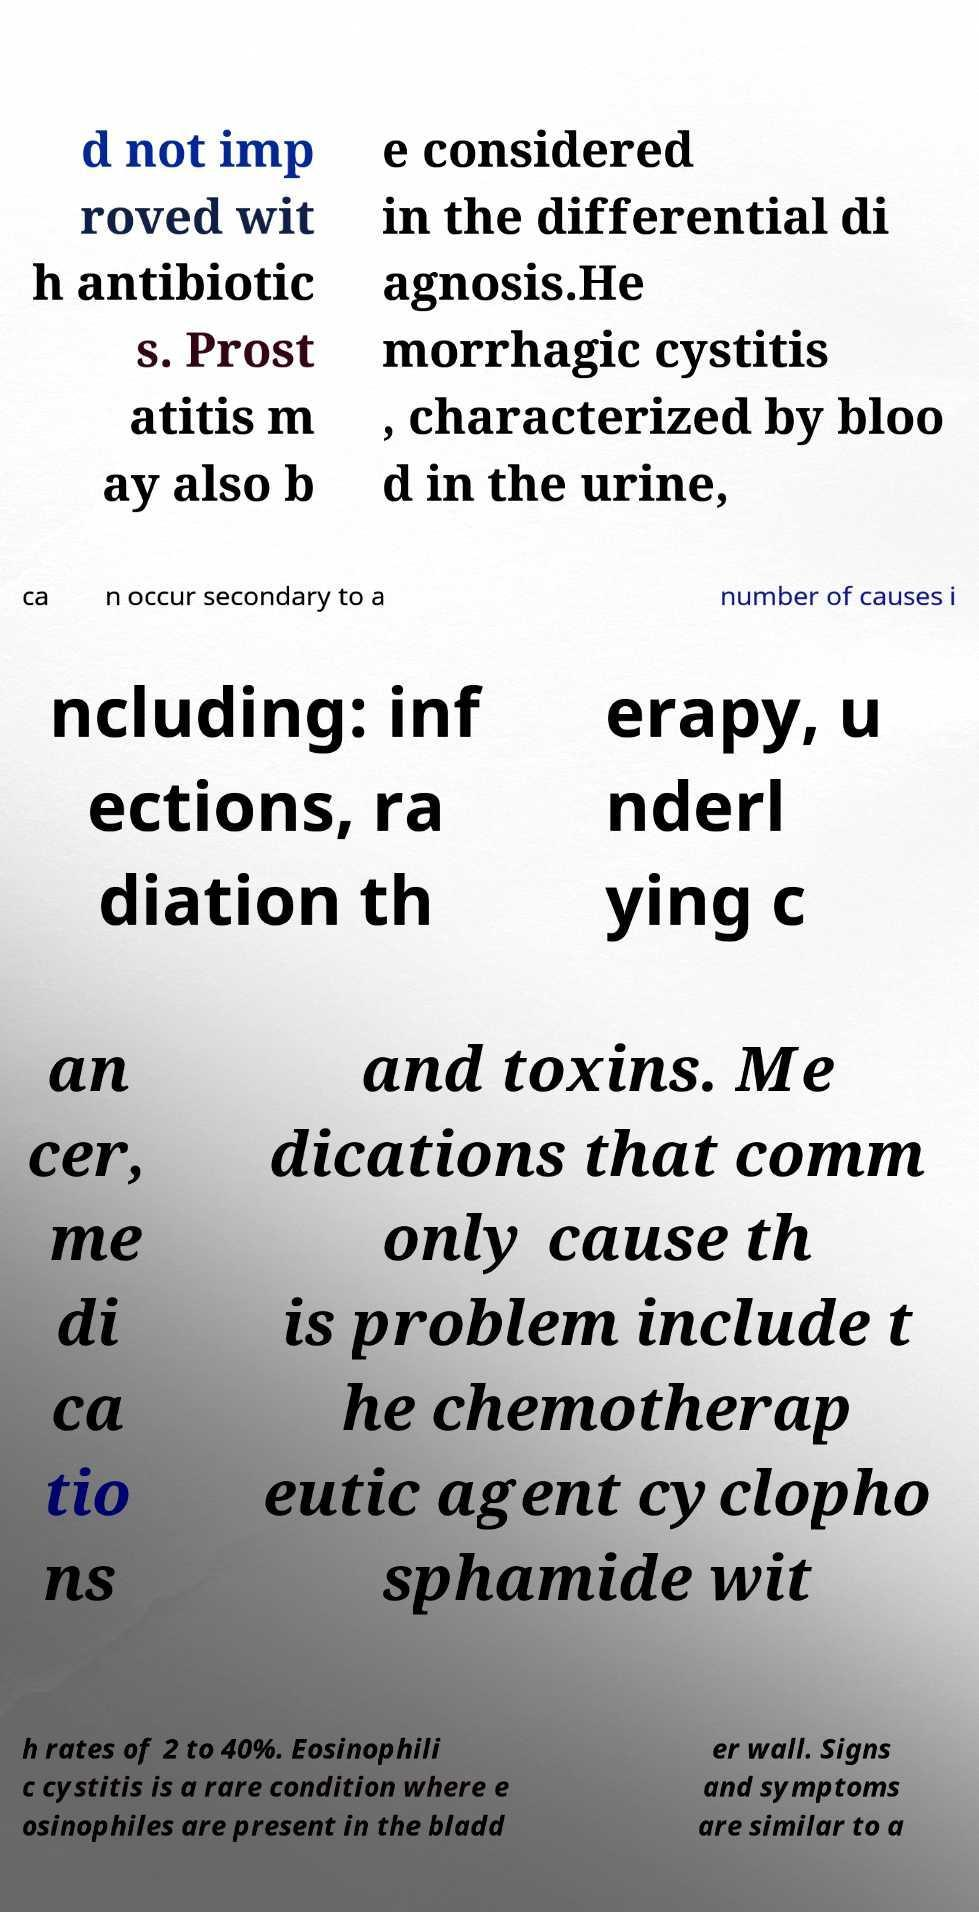Could you extract and type out the text from this image? d not imp roved wit h antibiotic s. Prost atitis m ay also b e considered in the differential di agnosis.He morrhagic cystitis , characterized by bloo d in the urine, ca n occur secondary to a number of causes i ncluding: inf ections, ra diation th erapy, u nderl ying c an cer, me di ca tio ns and toxins. Me dications that comm only cause th is problem include t he chemotherap eutic agent cyclopho sphamide wit h rates of 2 to 40%. Eosinophili c cystitis is a rare condition where e osinophiles are present in the bladd er wall. Signs and symptoms are similar to a 